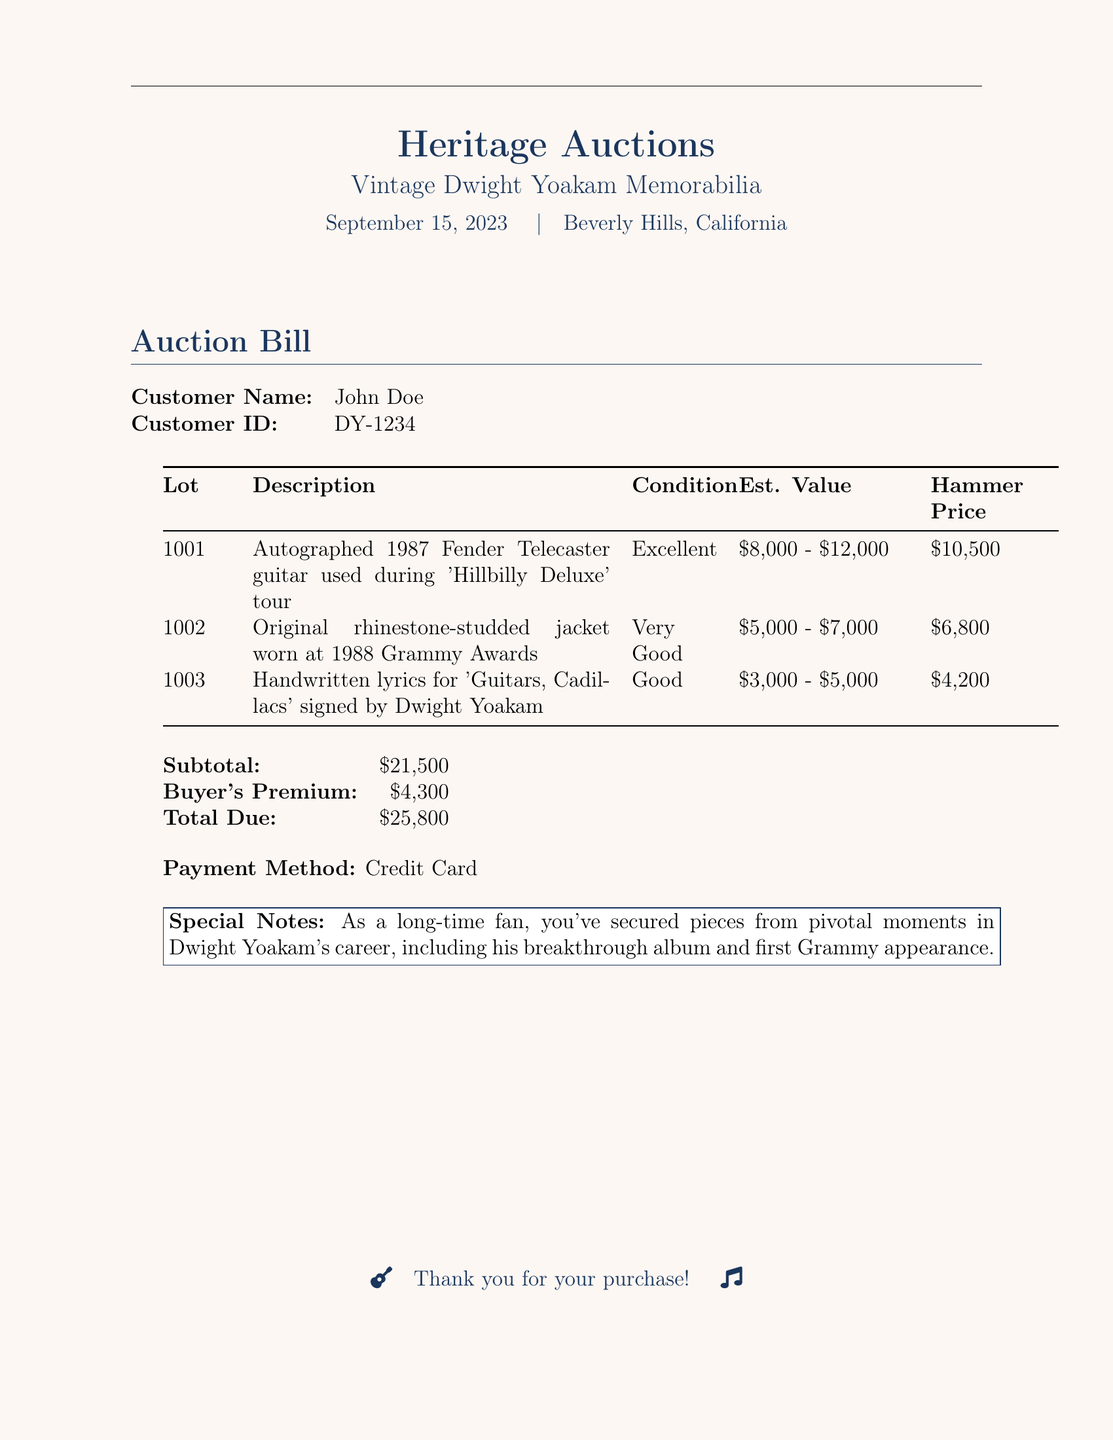What is the customer name? The customer name is given at the top of the invoice section of the document.
Answer: John Doe What is the customer ID? The customer ID is provided alongside the customer name in the document.
Answer: DY-1234 What is the estimated value range of the autographed guitar? The estimated value is specified in the auction bill under the description of the autographed guitar.
Answer: $8,000 - $12,000 What was the hammer price for the rhinestone-studded jacket? The hammer price can be found in the auction bill table associated with the jacket.
Answer: $6,800 What is the total due amount? The total due is calculated at the bottom of the invoice and is found in the final summary section.
Answer: $25,800 How many items are listed in the auction bill? The number of items can be counted from the lots section in the document.
Answer: 3 What is the condition of the handwritten lyrics? The condition is stated in the auction bill next to the description of the handwritten lyrics.
Answer: Good What special note is mentioned in the bill? The special notes are provided at the end of the document and emphasize the significance of the purchased items.
Answer: As a long-time fan, you've secured pieces from pivotal moments in Dwight Yoakam's career, including his breakthrough album and first Grammy appearance 